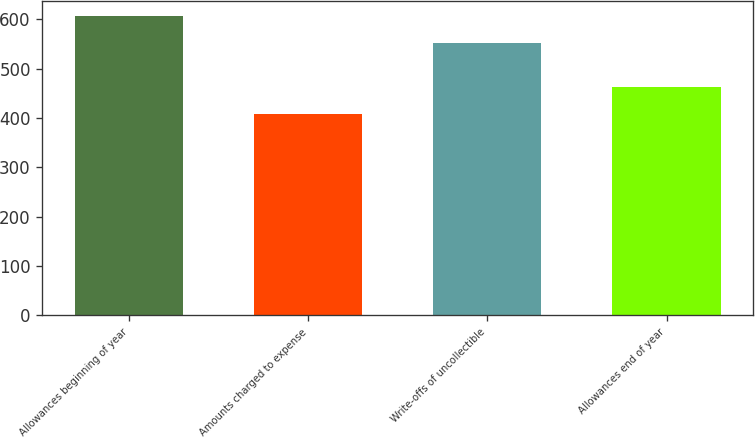Convert chart to OTSL. <chart><loc_0><loc_0><loc_500><loc_500><bar_chart><fcel>Allowances beginning of year<fcel>Amounts charged to expense<fcel>Write-offs of uncollectible<fcel>Allowances end of year<nl><fcel>607<fcel>407<fcel>552<fcel>462<nl></chart> 